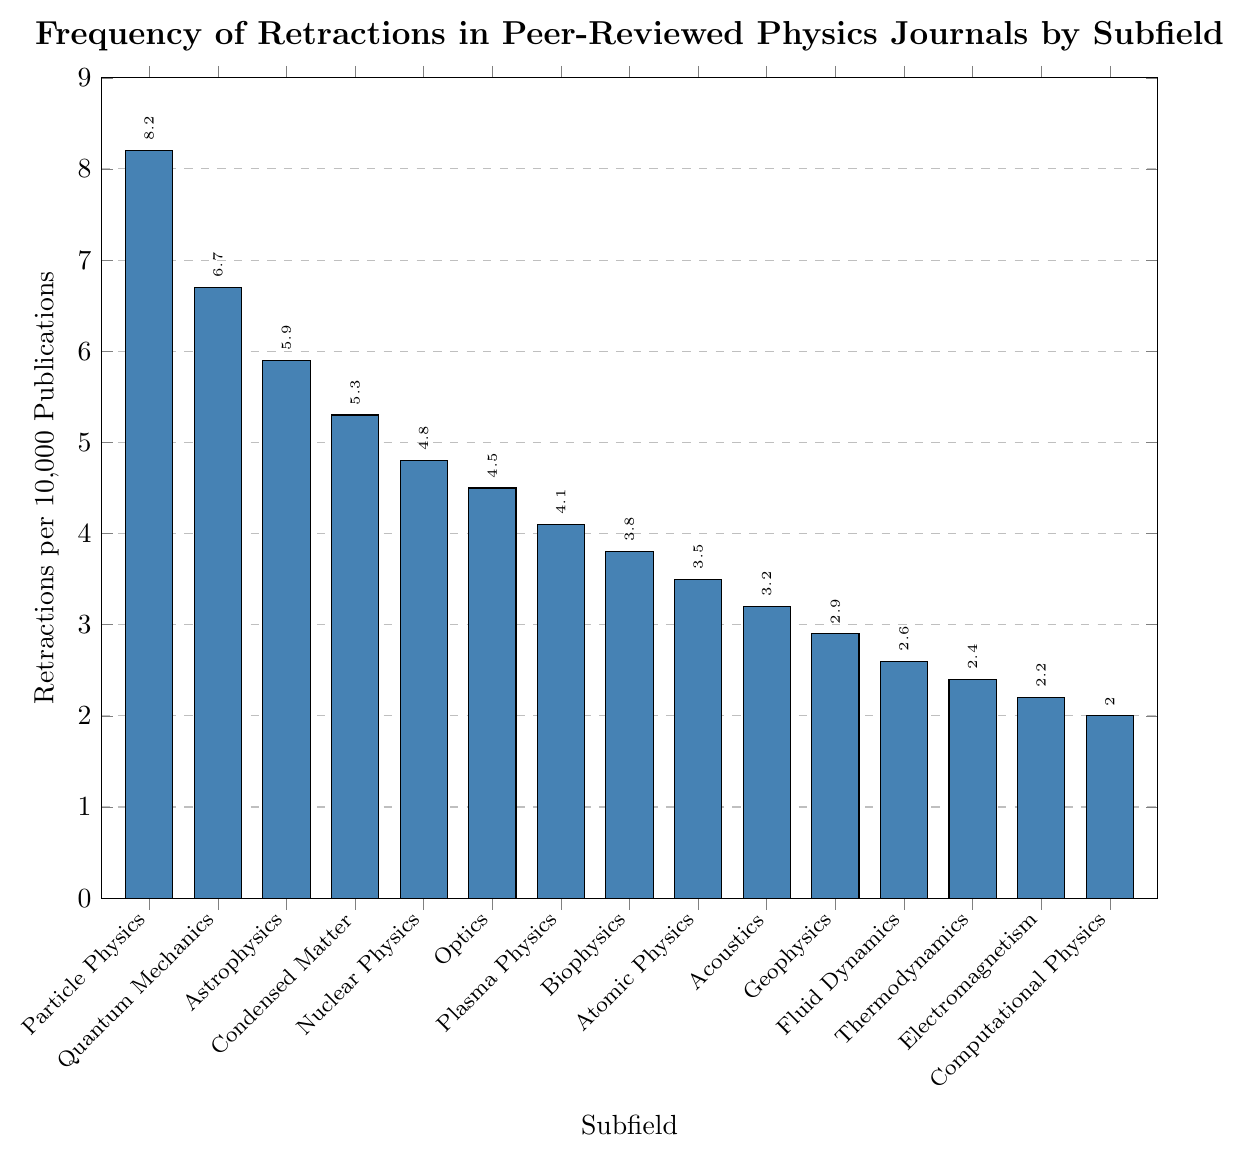What subfield has the highest number of retractions per 10,000 publications? To find the subfield with the highest number of retractions per 10,000 publications, look for the tallest bar in the chart. The tallest bar corresponds to Particle Physics.
Answer: Particle Physics Which subfield has fewer retractions, Quantum Mechanics or Nuclear Physics? Compare the heights of the bars for Quantum Mechanics and Nuclear Physics. Quantum Mechanics has a retraction rate of 6.7 per 10,000 publications, while Nuclear Physics has 4.8. Therefore, Nuclear Physics has fewer retractions.
Answer: Nuclear Physics What is the sum of retractions per 10,000 publications for Plasma Physics and Atomic Physics? Add the retraction rates of Plasma Physics (4.1) and Atomic Physics (3.5). So, 4.1 + 3.5 = 7.6.
Answer: 7.6 How much higher is the retraction rate for Particle Physics compared to Acoustics? Subtract the retraction rate of Acoustics (3.2) from that of Particle Physics (8.2). So, 8.2 - 3.2 = 5.0.
Answer: 5.0 Is the retraction rate for Biophysics greater than the overall average retraction rate across all subfields? First, calculate the overall average retraction rate by summing all given rates and dividing by the number of subfields. Then compare this average with the retraction rate for Biophysics (3.8). The sum of all retraction rates is 62.1, and there are 15 subfields, so the average is 62.1 / 15 ≈ 4.14. Biophysics has a retraction rate of 3.8, which is less than 4.14.
Answer: No Which subfields have a retraction rate below 3.0? Identify the bars that are shorter than the 3.0 mark on the y-axis. These bars correspond to Fluid Dynamics (2.6), Thermodynamics (2.4), Electromagnetism (2.2), and Computational Physics (2.0).
Answer: Fluid Dynamics, Thermodynamics, Electromagnetism, Computational Physics What is the difference in retraction rates between the highest and lowest subfields? Subtract the retraction rate of Computational Physics (2.0) from that of Particle Physics (8.2). So, 8.2 - 2.0 = 6.2.
Answer: 6.2 List the subfields in descending order of retraction rates. Rank the subfields based on the heights of their bars from tallest to shortest: Particle Physics, Quantum Mechanics, Astrophysics, Condensed Matter, Nuclear Physics, Optics, Plasma Physics, Biophysics, Atomic Physics, Acoustics, Geophysics, Fluid Dynamics, Thermodynamics, Electromagnetism, Computational Physics.
Answer: Particle Physics, Quantum Mechanics, Astrophysics, Condensed Matter, Nuclear Physics, Optics, Plasma Physics, Biophysics, Atomic Physics, Acoustics, Geophysics, Fluid Dynamics, Thermodynamics, Electromagnetism, Computational Physics What is the average retraction rate for the top 3 subfields? Identify the top 3 subfields: Particle Physics (8.2), Quantum Mechanics (6.7), and Astrophysics (5.9). Add these rates and divide by 3. So, (8.2 + 6.7 + 5.9) / 3 ≈ 6.93.
Answer: 6.93 